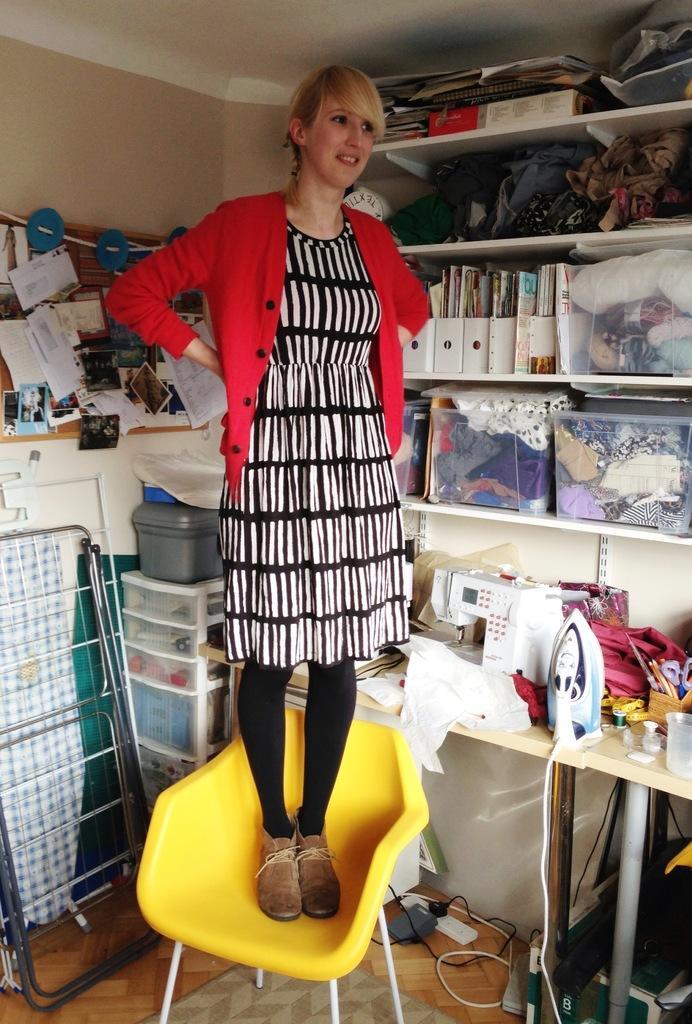Can you describe this image briefly? The image is inside the room. In the image there is a woman standing on chair behind the woman there is a table. On table we can see a iron box,jar,threads,clothes and a machine. On right side there is a shelf on shelf we can see some books,papers,clothes,box. On left side there is a box,chair,frame,papers,wall which is in pink color and roof on top. 